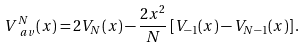<formula> <loc_0><loc_0><loc_500><loc_500>V _ { \ a v } ^ { N } ( x ) = 2 V _ { N } ( x ) - \frac { 2 x ^ { 2 } } { N } \left [ V _ { - 1 } ( x ) - V _ { N - 1 } ( x ) \right ] .</formula> 